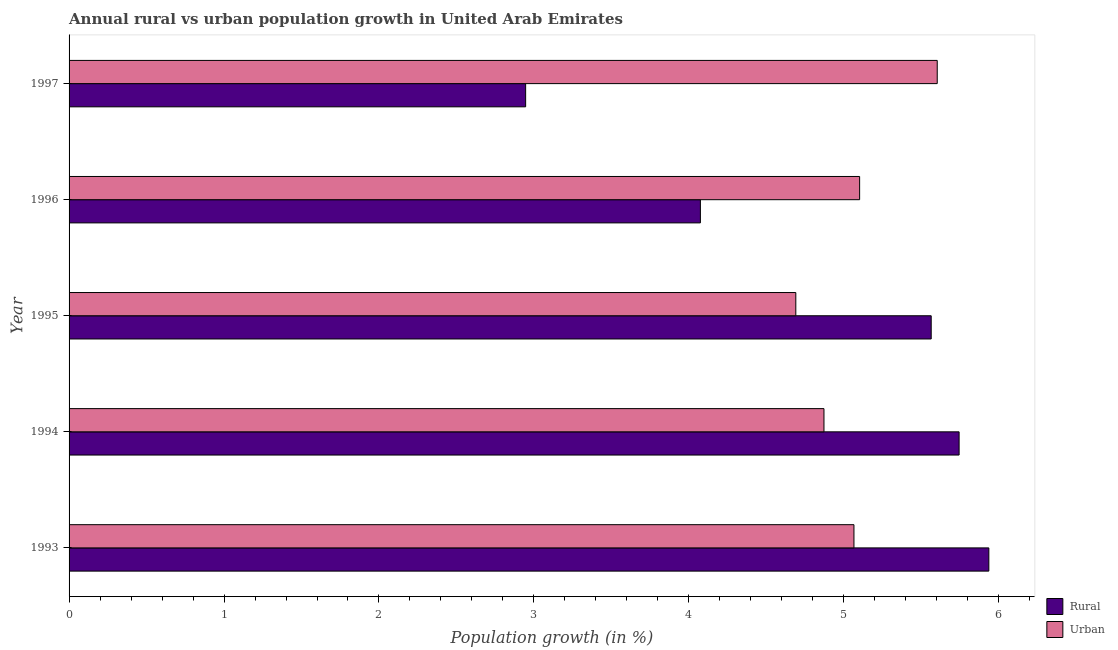How many different coloured bars are there?
Offer a very short reply. 2. Are the number of bars per tick equal to the number of legend labels?
Provide a short and direct response. Yes. Are the number of bars on each tick of the Y-axis equal?
Provide a short and direct response. Yes. How many bars are there on the 5th tick from the top?
Your answer should be compact. 2. How many bars are there on the 4th tick from the bottom?
Provide a succinct answer. 2. What is the label of the 1st group of bars from the top?
Make the answer very short. 1997. What is the rural population growth in 1995?
Offer a very short reply. 5.56. Across all years, what is the maximum rural population growth?
Make the answer very short. 5.94. Across all years, what is the minimum urban population growth?
Ensure brevity in your answer.  4.69. In which year was the urban population growth maximum?
Make the answer very short. 1997. What is the total urban population growth in the graph?
Your answer should be very brief. 25.33. What is the difference between the rural population growth in 1993 and that in 1994?
Provide a succinct answer. 0.19. What is the difference between the rural population growth in 1997 and the urban population growth in 1993?
Keep it short and to the point. -2.12. What is the average rural population growth per year?
Keep it short and to the point. 4.85. In the year 1994, what is the difference between the rural population growth and urban population growth?
Ensure brevity in your answer.  0.87. What is the ratio of the rural population growth in 1994 to that in 1996?
Your response must be concise. 1.41. What is the difference between the highest and the second highest rural population growth?
Provide a short and direct response. 0.19. What is the difference between the highest and the lowest rural population growth?
Your answer should be very brief. 2.99. Is the sum of the urban population growth in 1995 and 1996 greater than the maximum rural population growth across all years?
Keep it short and to the point. Yes. What does the 1st bar from the top in 1995 represents?
Your answer should be compact. Urban . What does the 2nd bar from the bottom in 1994 represents?
Ensure brevity in your answer.  Urban . Are all the bars in the graph horizontal?
Your response must be concise. Yes. How many years are there in the graph?
Provide a short and direct response. 5. Are the values on the major ticks of X-axis written in scientific E-notation?
Make the answer very short. No. Does the graph contain grids?
Your response must be concise. No. Where does the legend appear in the graph?
Keep it short and to the point. Bottom right. How are the legend labels stacked?
Offer a terse response. Vertical. What is the title of the graph?
Your response must be concise. Annual rural vs urban population growth in United Arab Emirates. What is the label or title of the X-axis?
Make the answer very short. Population growth (in %). What is the Population growth (in %) in Rural in 1993?
Ensure brevity in your answer.  5.94. What is the Population growth (in %) of Urban  in 1993?
Make the answer very short. 5.07. What is the Population growth (in %) of Rural in 1994?
Your response must be concise. 5.74. What is the Population growth (in %) in Urban  in 1994?
Give a very brief answer. 4.87. What is the Population growth (in %) in Rural in 1995?
Make the answer very short. 5.56. What is the Population growth (in %) in Urban  in 1995?
Provide a succinct answer. 4.69. What is the Population growth (in %) in Rural in 1996?
Make the answer very short. 4.07. What is the Population growth (in %) of Urban  in 1996?
Your answer should be very brief. 5.1. What is the Population growth (in %) in Rural in 1997?
Keep it short and to the point. 2.95. What is the Population growth (in %) in Urban  in 1997?
Provide a succinct answer. 5.6. Across all years, what is the maximum Population growth (in %) of Rural?
Keep it short and to the point. 5.94. Across all years, what is the maximum Population growth (in %) in Urban ?
Offer a very short reply. 5.6. Across all years, what is the minimum Population growth (in %) in Rural?
Make the answer very short. 2.95. Across all years, what is the minimum Population growth (in %) in Urban ?
Ensure brevity in your answer.  4.69. What is the total Population growth (in %) in Rural in the graph?
Provide a succinct answer. 24.26. What is the total Population growth (in %) of Urban  in the graph?
Make the answer very short. 25.33. What is the difference between the Population growth (in %) in Rural in 1993 and that in 1994?
Keep it short and to the point. 0.19. What is the difference between the Population growth (in %) in Urban  in 1993 and that in 1994?
Provide a short and direct response. 0.19. What is the difference between the Population growth (in %) in Rural in 1993 and that in 1995?
Provide a short and direct response. 0.37. What is the difference between the Population growth (in %) of Urban  in 1993 and that in 1995?
Keep it short and to the point. 0.38. What is the difference between the Population growth (in %) in Rural in 1993 and that in 1996?
Your answer should be compact. 1.86. What is the difference between the Population growth (in %) of Urban  in 1993 and that in 1996?
Make the answer very short. -0.04. What is the difference between the Population growth (in %) of Rural in 1993 and that in 1997?
Make the answer very short. 2.99. What is the difference between the Population growth (in %) of Urban  in 1993 and that in 1997?
Provide a short and direct response. -0.54. What is the difference between the Population growth (in %) in Rural in 1994 and that in 1995?
Ensure brevity in your answer.  0.18. What is the difference between the Population growth (in %) of Urban  in 1994 and that in 1995?
Your response must be concise. 0.18. What is the difference between the Population growth (in %) of Rural in 1994 and that in 1996?
Offer a terse response. 1.67. What is the difference between the Population growth (in %) of Urban  in 1994 and that in 1996?
Provide a short and direct response. -0.23. What is the difference between the Population growth (in %) of Rural in 1994 and that in 1997?
Your response must be concise. 2.8. What is the difference between the Population growth (in %) of Urban  in 1994 and that in 1997?
Provide a succinct answer. -0.73. What is the difference between the Population growth (in %) in Rural in 1995 and that in 1996?
Your answer should be very brief. 1.49. What is the difference between the Population growth (in %) of Urban  in 1995 and that in 1996?
Offer a very short reply. -0.41. What is the difference between the Population growth (in %) of Rural in 1995 and that in 1997?
Your response must be concise. 2.62. What is the difference between the Population growth (in %) of Urban  in 1995 and that in 1997?
Make the answer very short. -0.91. What is the difference between the Population growth (in %) of Rural in 1996 and that in 1997?
Ensure brevity in your answer.  1.13. What is the difference between the Population growth (in %) of Urban  in 1996 and that in 1997?
Keep it short and to the point. -0.5. What is the difference between the Population growth (in %) of Rural in 1993 and the Population growth (in %) of Urban  in 1994?
Give a very brief answer. 1.06. What is the difference between the Population growth (in %) in Rural in 1993 and the Population growth (in %) in Urban  in 1995?
Ensure brevity in your answer.  1.25. What is the difference between the Population growth (in %) of Rural in 1993 and the Population growth (in %) of Urban  in 1996?
Your answer should be compact. 0.83. What is the difference between the Population growth (in %) in Rural in 1993 and the Population growth (in %) in Urban  in 1997?
Give a very brief answer. 0.33. What is the difference between the Population growth (in %) in Rural in 1994 and the Population growth (in %) in Urban  in 1995?
Provide a short and direct response. 1.05. What is the difference between the Population growth (in %) in Rural in 1994 and the Population growth (in %) in Urban  in 1996?
Provide a short and direct response. 0.64. What is the difference between the Population growth (in %) in Rural in 1994 and the Population growth (in %) in Urban  in 1997?
Offer a very short reply. 0.14. What is the difference between the Population growth (in %) of Rural in 1995 and the Population growth (in %) of Urban  in 1996?
Your answer should be very brief. 0.46. What is the difference between the Population growth (in %) in Rural in 1995 and the Population growth (in %) in Urban  in 1997?
Offer a very short reply. -0.04. What is the difference between the Population growth (in %) in Rural in 1996 and the Population growth (in %) in Urban  in 1997?
Your answer should be compact. -1.53. What is the average Population growth (in %) of Rural per year?
Your answer should be very brief. 4.85. What is the average Population growth (in %) of Urban  per year?
Provide a succinct answer. 5.07. In the year 1993, what is the difference between the Population growth (in %) in Rural and Population growth (in %) in Urban ?
Your answer should be compact. 0.87. In the year 1994, what is the difference between the Population growth (in %) of Rural and Population growth (in %) of Urban ?
Give a very brief answer. 0.87. In the year 1995, what is the difference between the Population growth (in %) in Rural and Population growth (in %) in Urban ?
Your answer should be compact. 0.87. In the year 1996, what is the difference between the Population growth (in %) of Rural and Population growth (in %) of Urban ?
Your answer should be compact. -1.03. In the year 1997, what is the difference between the Population growth (in %) in Rural and Population growth (in %) in Urban ?
Provide a short and direct response. -2.66. What is the ratio of the Population growth (in %) in Rural in 1993 to that in 1994?
Keep it short and to the point. 1.03. What is the ratio of the Population growth (in %) of Urban  in 1993 to that in 1994?
Your answer should be compact. 1.04. What is the ratio of the Population growth (in %) of Rural in 1993 to that in 1995?
Keep it short and to the point. 1.07. What is the ratio of the Population growth (in %) of Rural in 1993 to that in 1996?
Keep it short and to the point. 1.46. What is the ratio of the Population growth (in %) in Rural in 1993 to that in 1997?
Keep it short and to the point. 2.01. What is the ratio of the Population growth (in %) in Urban  in 1993 to that in 1997?
Ensure brevity in your answer.  0.9. What is the ratio of the Population growth (in %) in Rural in 1994 to that in 1995?
Offer a very short reply. 1.03. What is the ratio of the Population growth (in %) of Urban  in 1994 to that in 1995?
Provide a short and direct response. 1.04. What is the ratio of the Population growth (in %) of Rural in 1994 to that in 1996?
Your answer should be compact. 1.41. What is the ratio of the Population growth (in %) of Urban  in 1994 to that in 1996?
Your response must be concise. 0.95. What is the ratio of the Population growth (in %) in Rural in 1994 to that in 1997?
Provide a succinct answer. 1.95. What is the ratio of the Population growth (in %) of Urban  in 1994 to that in 1997?
Offer a terse response. 0.87. What is the ratio of the Population growth (in %) of Rural in 1995 to that in 1996?
Keep it short and to the point. 1.37. What is the ratio of the Population growth (in %) in Urban  in 1995 to that in 1996?
Ensure brevity in your answer.  0.92. What is the ratio of the Population growth (in %) in Rural in 1995 to that in 1997?
Make the answer very short. 1.89. What is the ratio of the Population growth (in %) of Urban  in 1995 to that in 1997?
Provide a short and direct response. 0.84. What is the ratio of the Population growth (in %) of Rural in 1996 to that in 1997?
Keep it short and to the point. 1.38. What is the ratio of the Population growth (in %) of Urban  in 1996 to that in 1997?
Offer a very short reply. 0.91. What is the difference between the highest and the second highest Population growth (in %) in Rural?
Provide a succinct answer. 0.19. What is the difference between the highest and the second highest Population growth (in %) in Urban ?
Give a very brief answer. 0.5. What is the difference between the highest and the lowest Population growth (in %) in Rural?
Offer a very short reply. 2.99. What is the difference between the highest and the lowest Population growth (in %) of Urban ?
Your response must be concise. 0.91. 